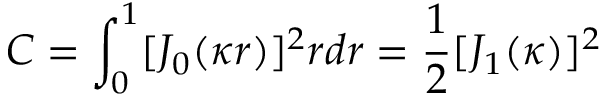Convert formula to latex. <formula><loc_0><loc_0><loc_500><loc_500>C = \int _ { 0 } ^ { 1 } [ J _ { 0 } ( \kappa r ) ] ^ { 2 } r d r = \frac { 1 } { 2 } [ J _ { 1 } ( \kappa ) ] ^ { 2 }</formula> 